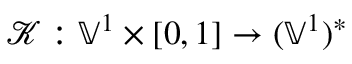<formula> <loc_0><loc_0><loc_500><loc_500>\mathcal { K } \colon \mathbb { V } ^ { 1 } \times [ 0 , 1 ] \to ( \mathbb { V } ^ { 1 } ) ^ { * }</formula> 